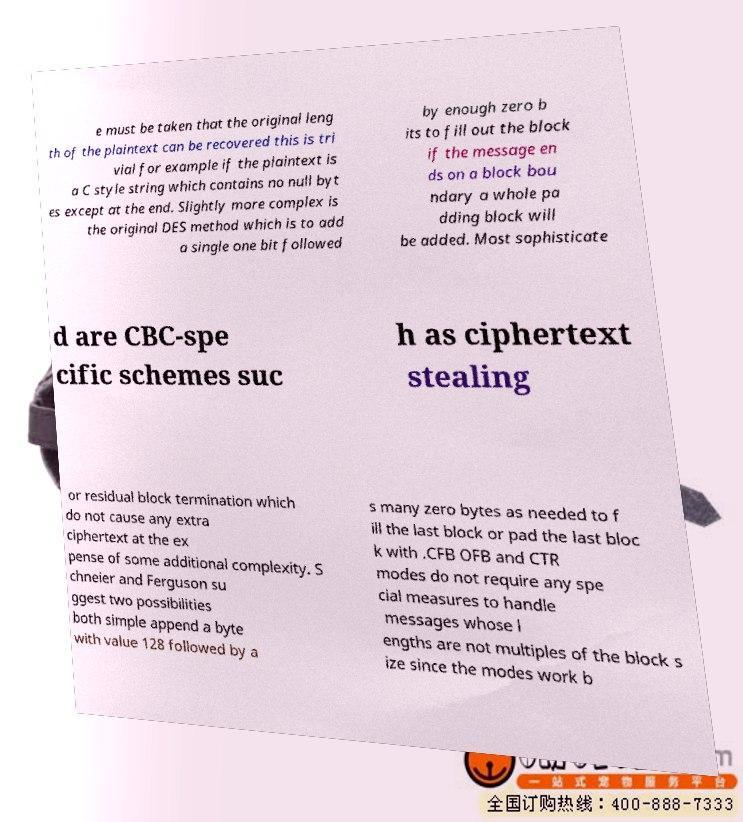Could you extract and type out the text from this image? e must be taken that the original leng th of the plaintext can be recovered this is tri vial for example if the plaintext is a C style string which contains no null byt es except at the end. Slightly more complex is the original DES method which is to add a single one bit followed by enough zero b its to fill out the block if the message en ds on a block bou ndary a whole pa dding block will be added. Most sophisticate d are CBC-spe cific schemes suc h as ciphertext stealing or residual block termination which do not cause any extra ciphertext at the ex pense of some additional complexity. S chneier and Ferguson su ggest two possibilities both simple append a byte with value 128 followed by a s many zero bytes as needed to f ill the last block or pad the last bloc k with .CFB OFB and CTR modes do not require any spe cial measures to handle messages whose l engths are not multiples of the block s ize since the modes work b 